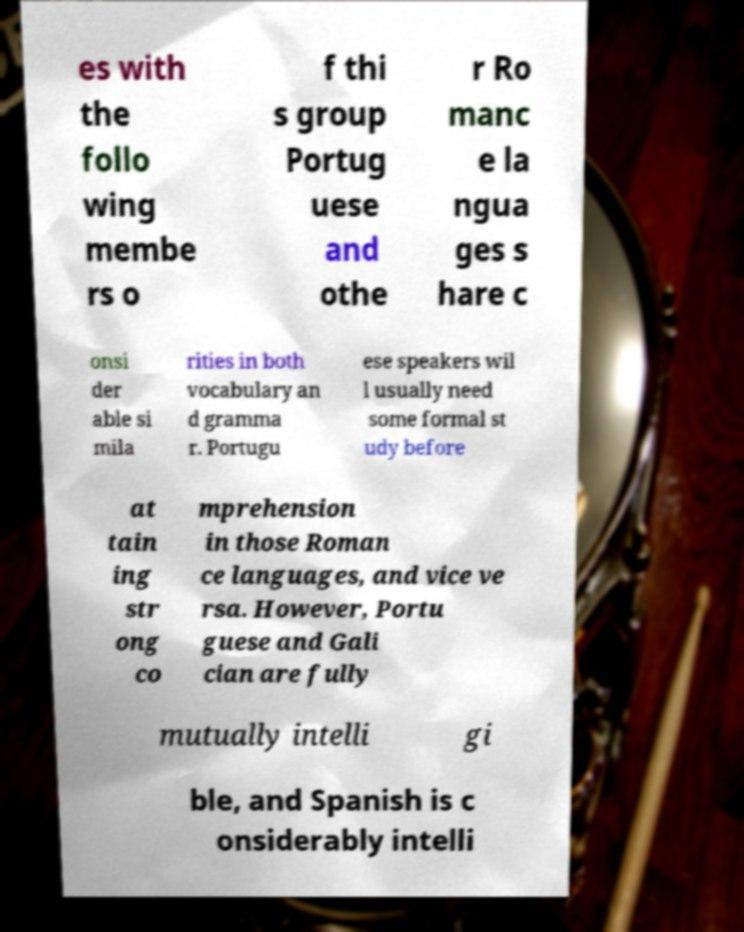Could you assist in decoding the text presented in this image and type it out clearly? es with the follo wing membe rs o f thi s group Portug uese and othe r Ro manc e la ngua ges s hare c onsi der able si mila rities in both vocabulary an d gramma r. Portugu ese speakers wil l usually need some formal st udy before at tain ing str ong co mprehension in those Roman ce languages, and vice ve rsa. However, Portu guese and Gali cian are fully mutually intelli gi ble, and Spanish is c onsiderably intelli 